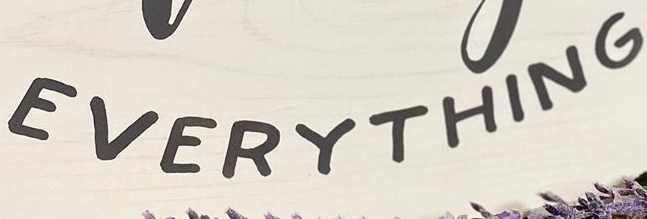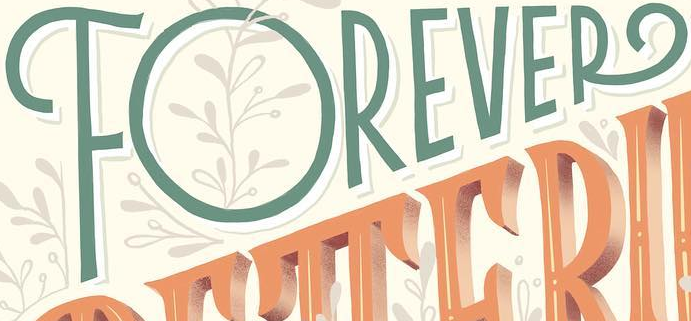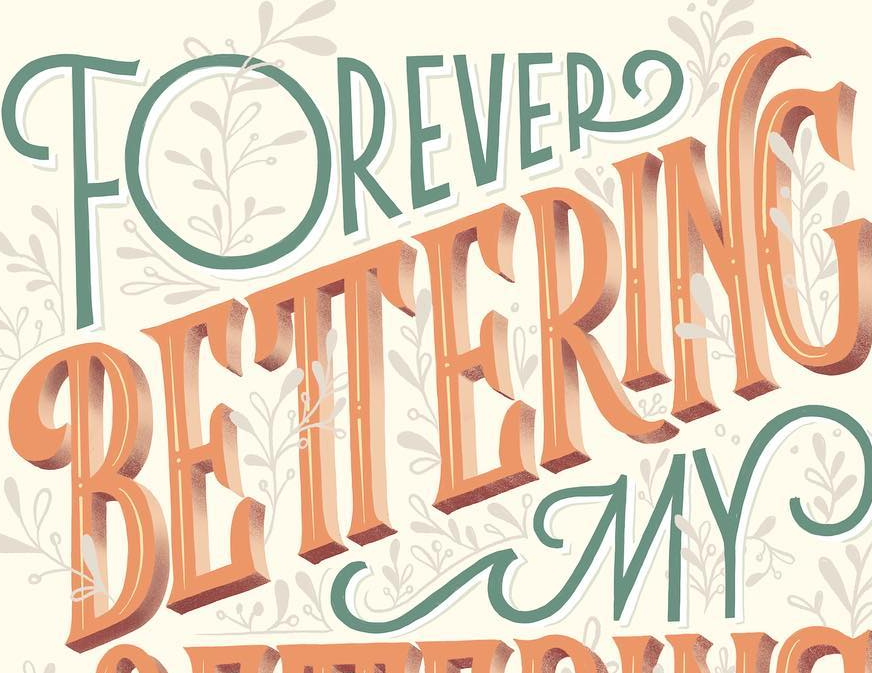Read the text content from these images in order, separated by a semicolon. EVERYTHING; FOREVER; BETTERING 